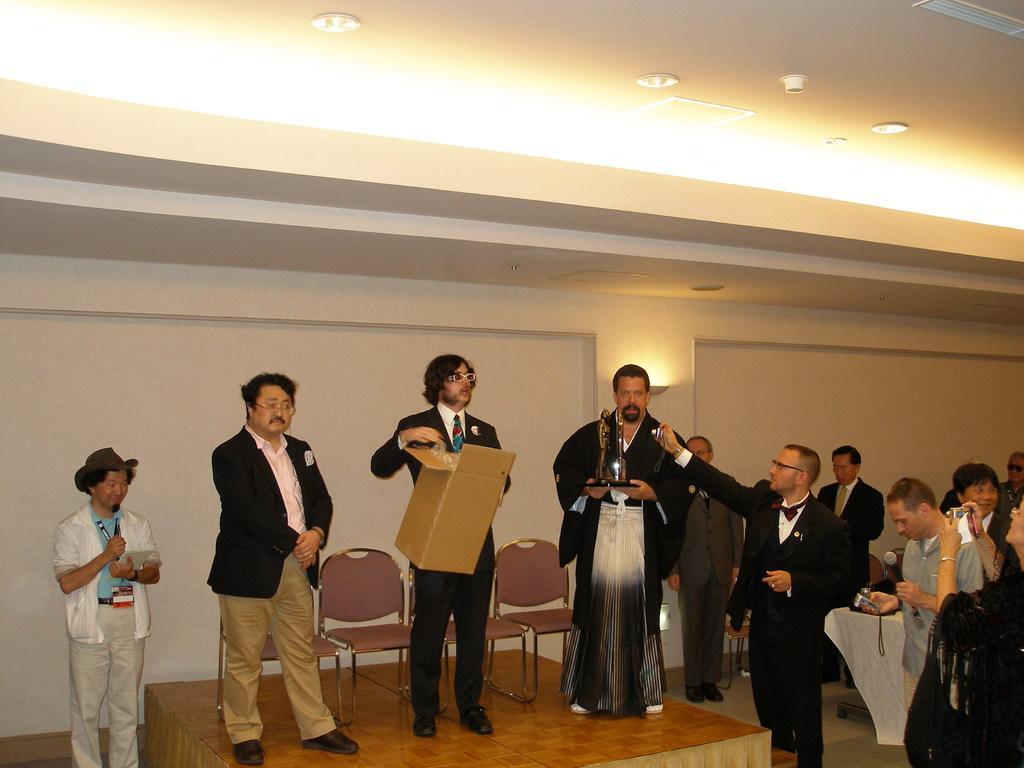Please provide a concise description of this image. In this image there is a stage on which there are three persons. The man in the middle is holding the box. While the man on the right side is holding the shield. On the right side there is a man who is standing on the floor is taking the picture with the camera. At the top there is ceiling with the lights. On the left side there is another man who is standing on the floor by holding the book. On the right side there are few other people who are taking the pictures with the cameras, 